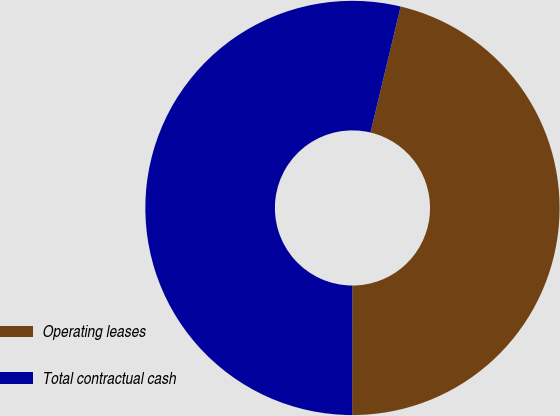<chart> <loc_0><loc_0><loc_500><loc_500><pie_chart><fcel>Operating leases<fcel>Total contractual cash<nl><fcel>46.29%<fcel>53.71%<nl></chart> 